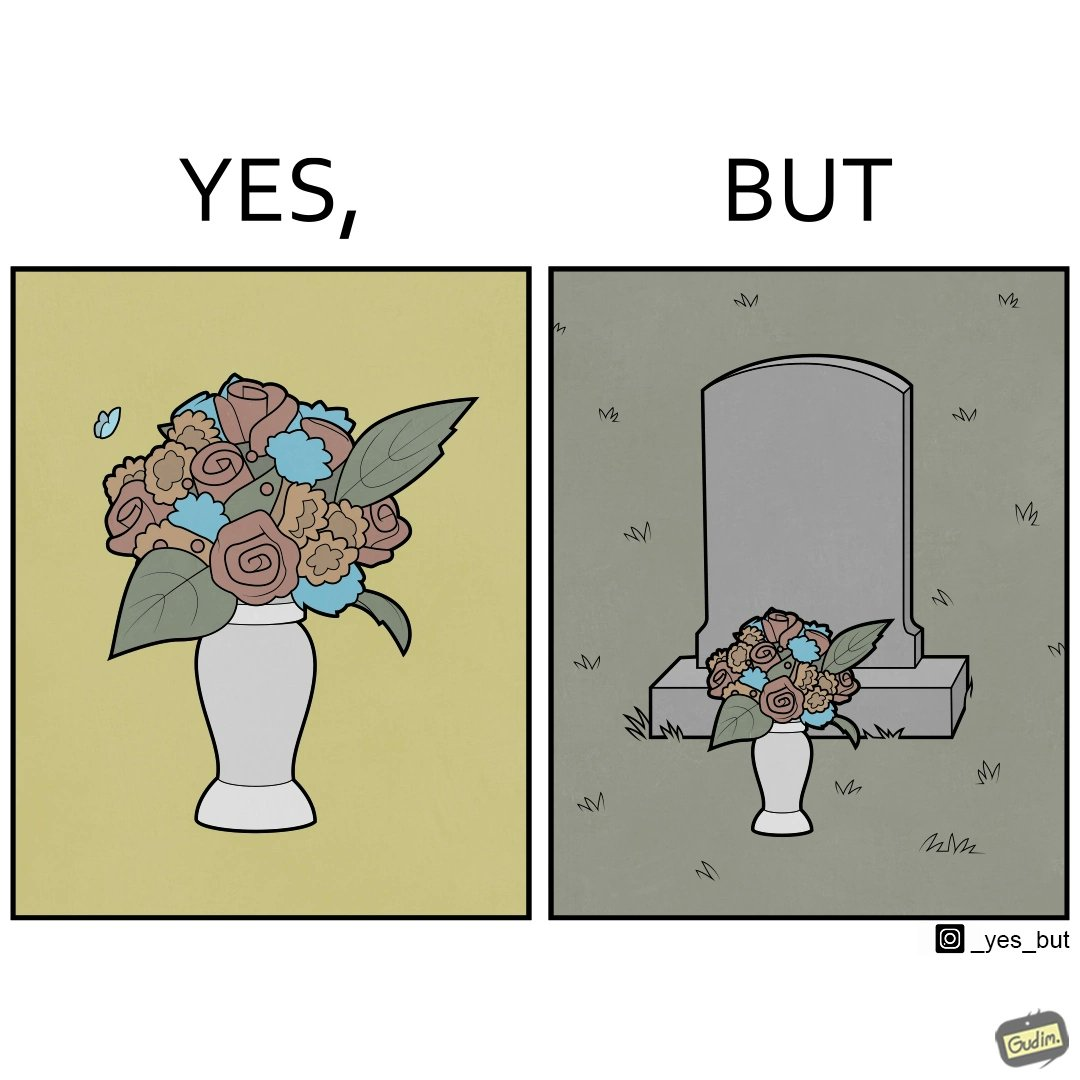What do you see in each half of this image? In the left part of the image: a beautiful vase of full of different beautiful flowers In the right part of the image: a beautiful vase of full of different beautiful flowers put in front of someone's grave stone 